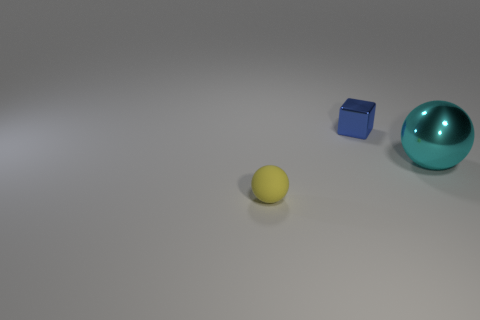Add 1 tiny brown cubes. How many objects exist? 4 Subtract all cubes. How many objects are left? 2 Subtract all big cyan metal balls. Subtract all shiny balls. How many objects are left? 1 Add 3 yellow rubber balls. How many yellow rubber balls are left? 4 Add 2 big cyan things. How many big cyan things exist? 3 Subtract 0 red cylinders. How many objects are left? 3 